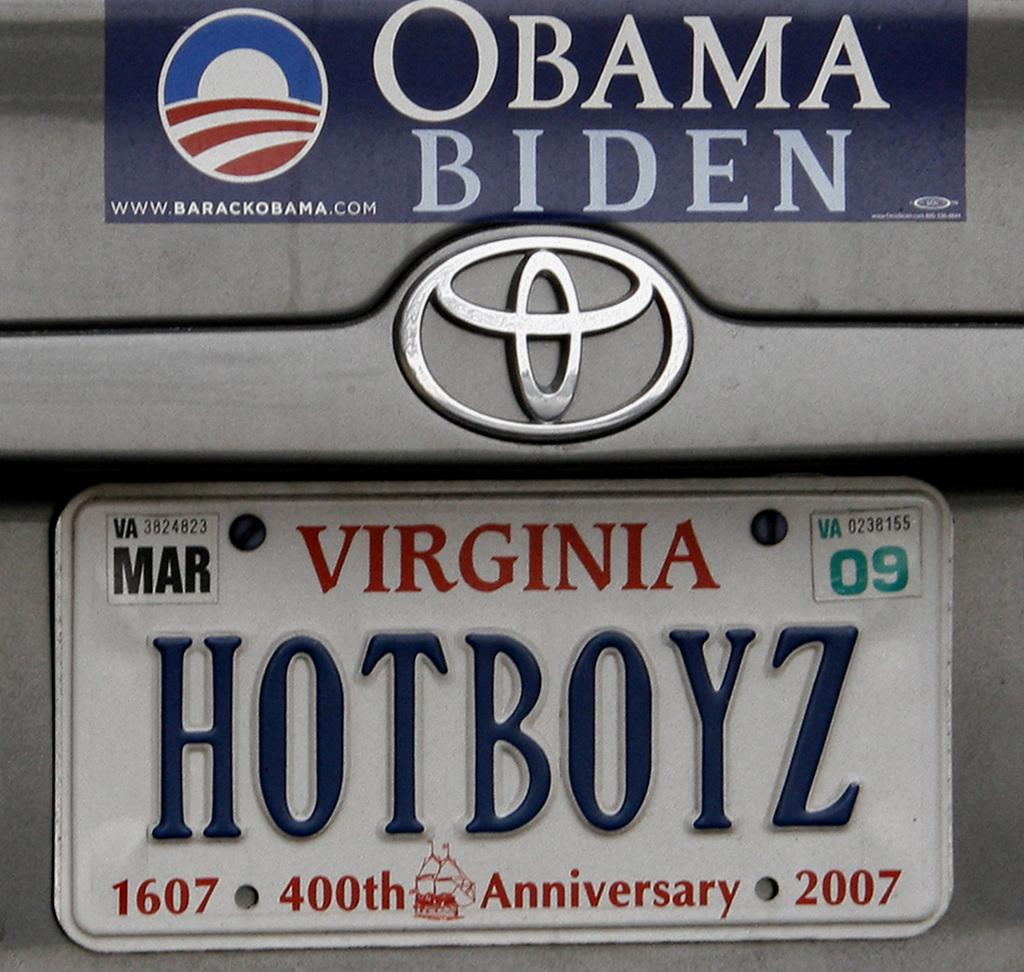<image>
Present a compact description of the photo's key features. A Virginia license plate with HOTBOYZ as the tag sits below an Obama/Biden bumper sticker. 